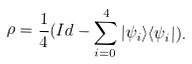Convert formula to latex. <formula><loc_0><loc_0><loc_500><loc_500>\rho = \frac { 1 } { 4 } ( I d - \sum _ { i = 0 } ^ { 4 } { | \psi _ { i } \rangle \langle \psi _ { i } | } ) .</formula> 